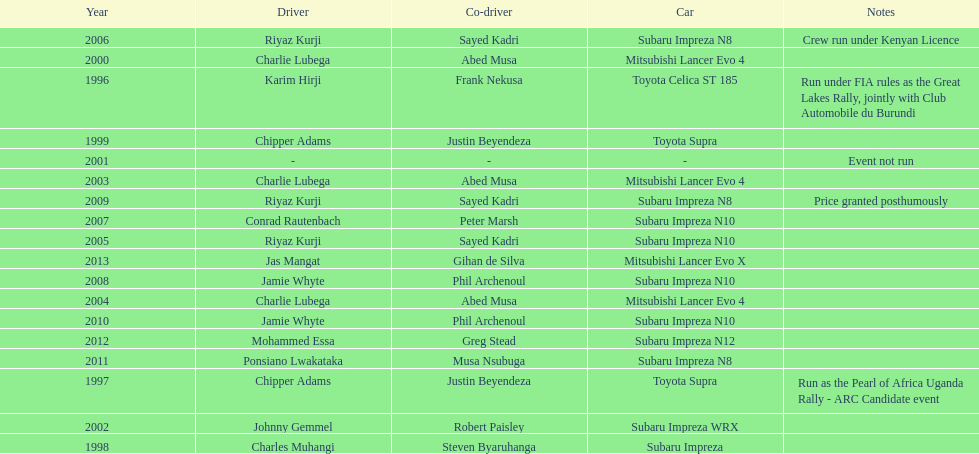What is the total number of times that the winning driver was driving a toyota supra? 2. 